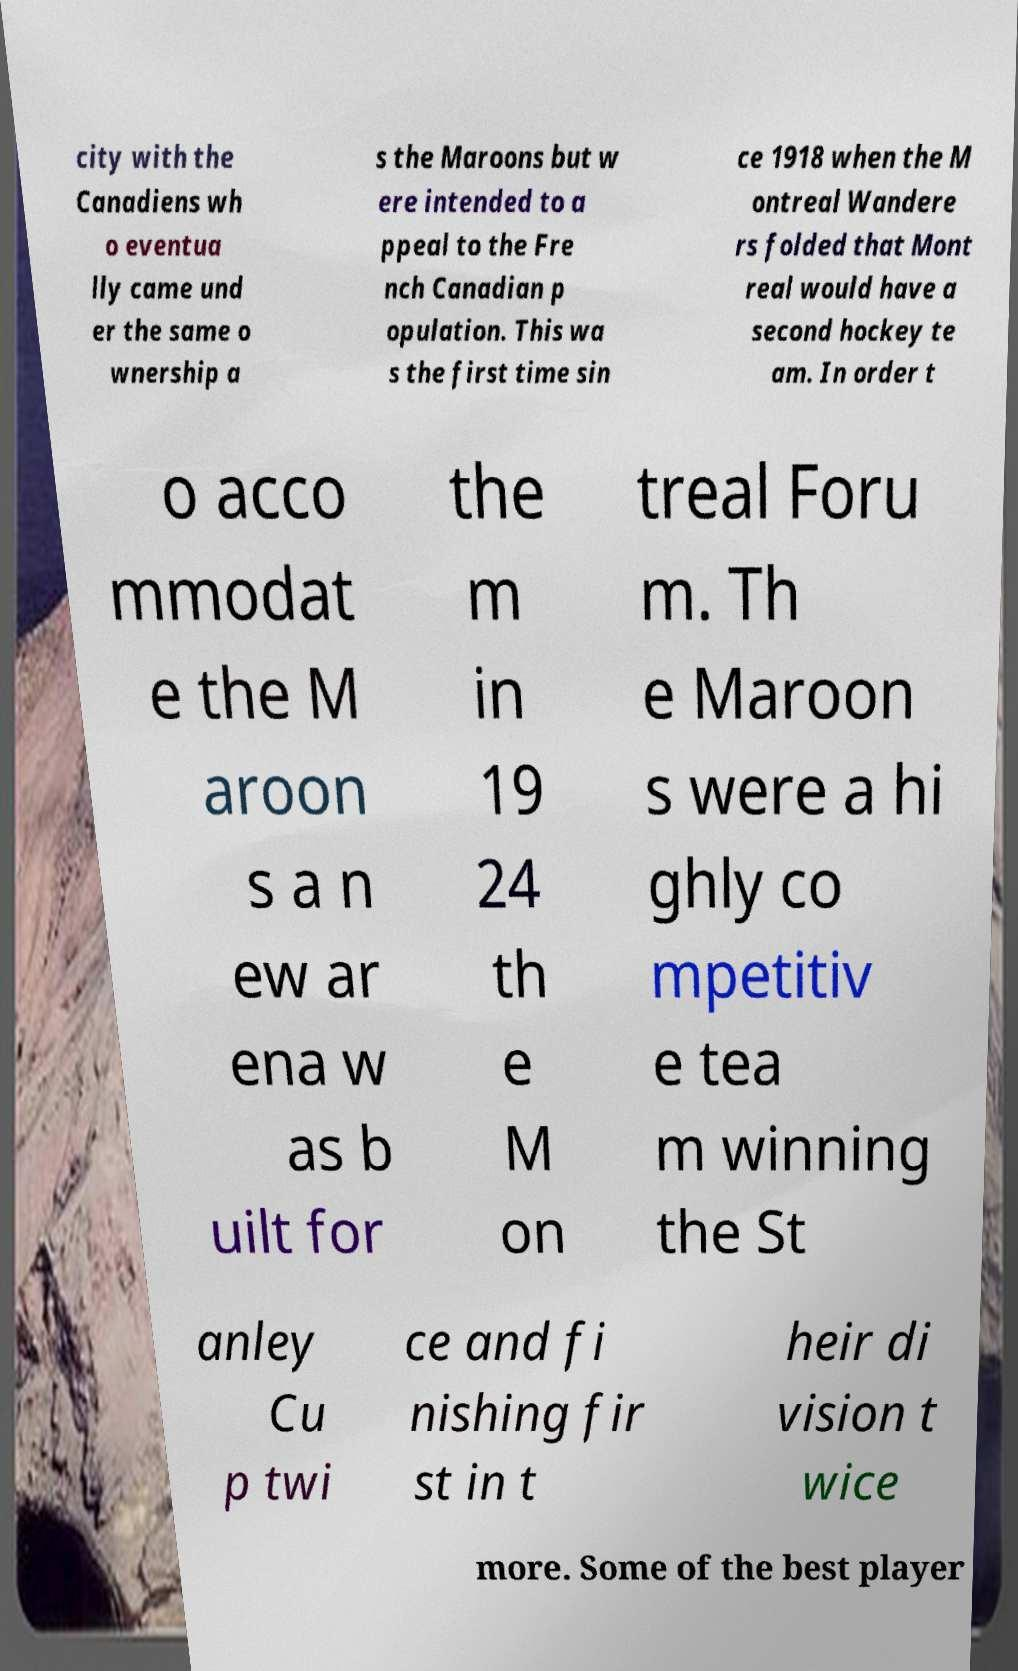For documentation purposes, I need the text within this image transcribed. Could you provide that? city with the Canadiens wh o eventua lly came und er the same o wnership a s the Maroons but w ere intended to a ppeal to the Fre nch Canadian p opulation. This wa s the first time sin ce 1918 when the M ontreal Wandere rs folded that Mont real would have a second hockey te am. In order t o acco mmodat e the M aroon s a n ew ar ena w as b uilt for the m in 19 24 th e M on treal Foru m. Th e Maroon s were a hi ghly co mpetitiv e tea m winning the St anley Cu p twi ce and fi nishing fir st in t heir di vision t wice more. Some of the best player 